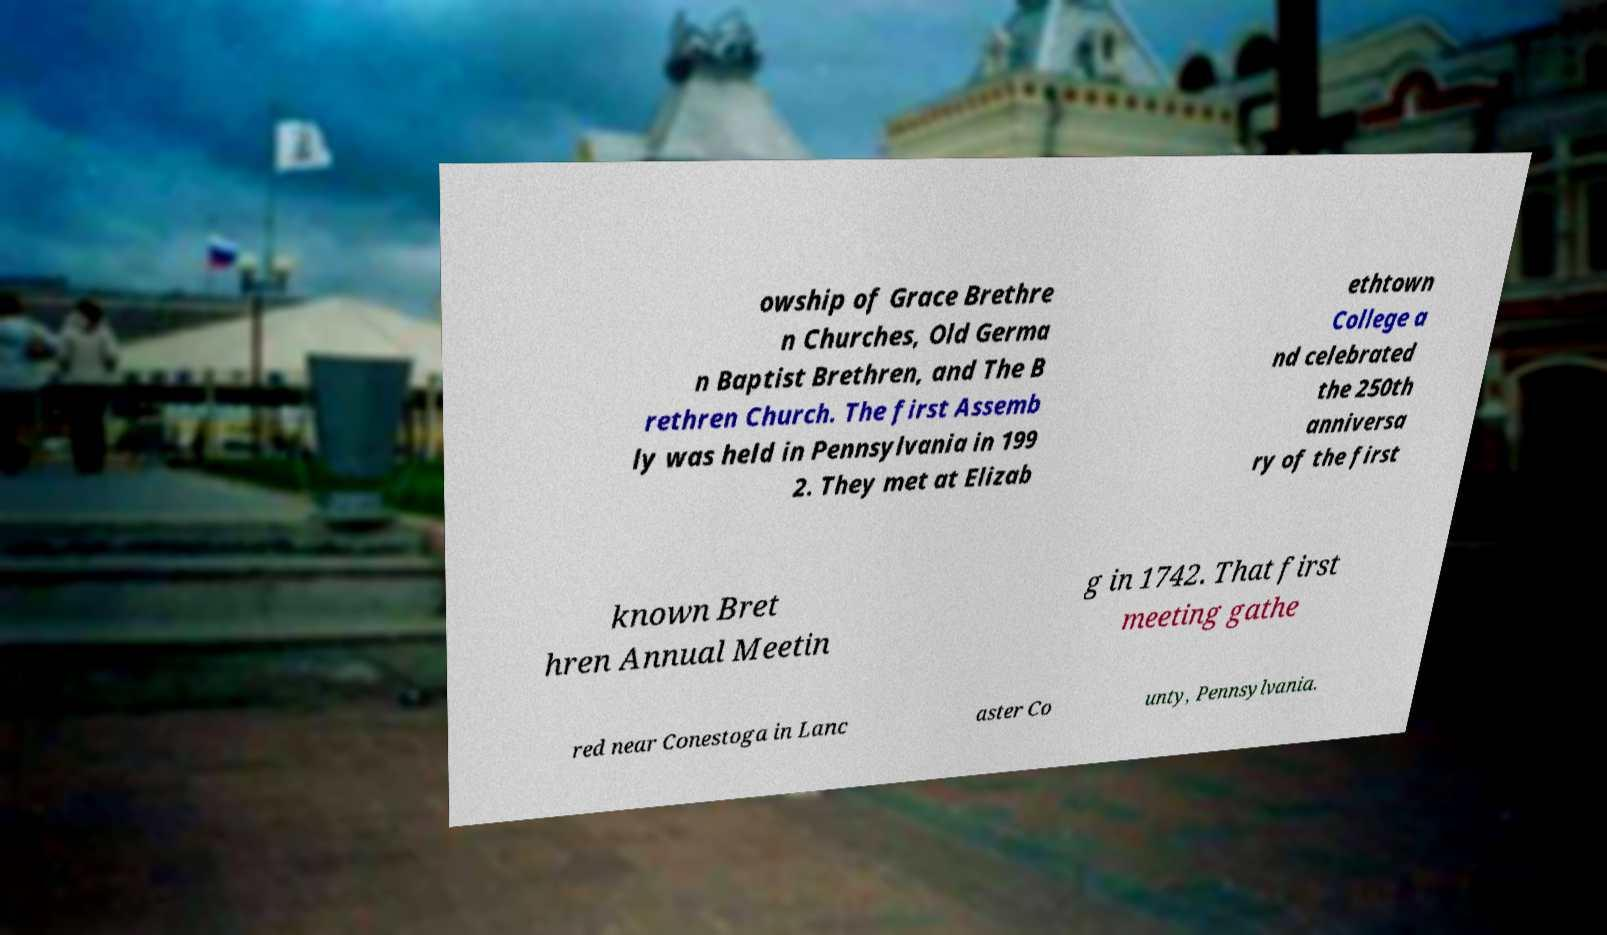There's text embedded in this image that I need extracted. Can you transcribe it verbatim? owship of Grace Brethre n Churches, Old Germa n Baptist Brethren, and The B rethren Church. The first Assemb ly was held in Pennsylvania in 199 2. They met at Elizab ethtown College a nd celebrated the 250th anniversa ry of the first known Bret hren Annual Meetin g in 1742. That first meeting gathe red near Conestoga in Lanc aster Co unty, Pennsylvania. 